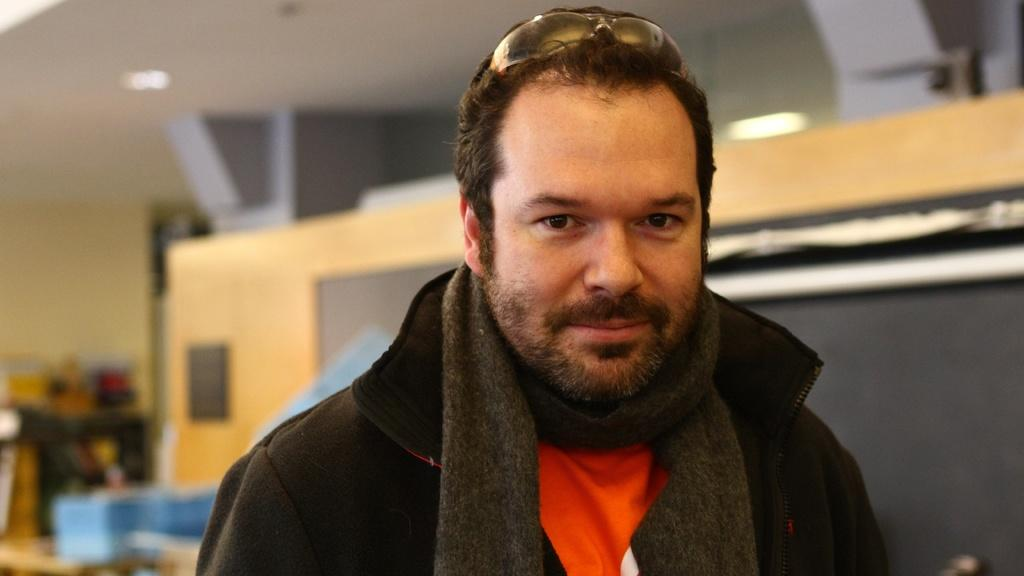Can you describe the person in the image? The person is in the blurred background of the image, so it is difficult to provide a detailed description. What type of knee injury is the person in the image suffering from? There is no information about any knee injuries in the image, as the person is in the blurred background and no such details are provided. 